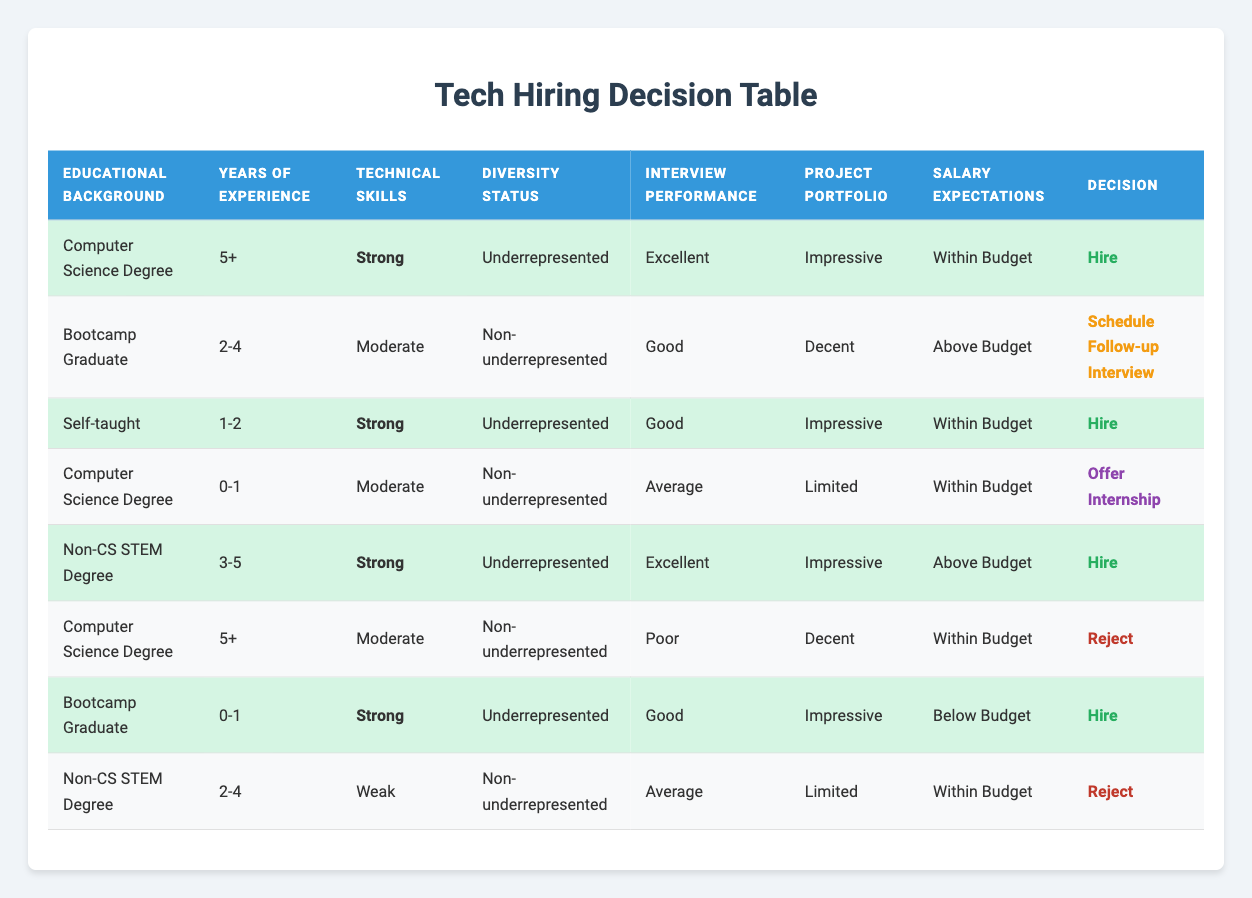What is the hiring decision for candidates with a Computer Science Degree and 5+ years of experience? According to the table, if a candidate has a Computer Science Degree and 5+ years of experience, it states they also have strong technical skills, underrepresented diversity status, excellent interview performance, an impressive project portfolio, and salary expectations within budget. Combining all these conditions leads to a hiring decision of "Hire."
Answer: Hire How many candidates were scheduled for a follow-up interview? There is one candidate in the table with the condition to schedule a follow-up interview. This candidate has a Bootcamp Graduate educational background, 2-4 years of experience, moderate technical skills, non-underrepresented diversity status, good interview performance, a decent project portfolio, and above-budget salary expectations.
Answer: 1 Is it true that all candidates with strong technical skills were hired? Reviewing the table shows that there are four candidates with strong technical skills. Out of these, three were hired and one (with a Non-CS STEM Degree, 2-4 years, and weak technical skills) was rejected. Therefore, it is false that all candidates with strong technical skills were hired.
Answer: No What is the decision for a candidate who is self-taught with 1-2 years of experience? The table indicates that a self-taught candidate with 1-2 years of experience has strong technical skills, is underrepresented in diversity, has good interview performance, an impressive project portfolio, and salary expectations within budget. The corresponding decision for them is "Hire."
Answer: Hire How does the decision for a candidate with a Non-CS STEM Degree and 3-5 years compare to one with a Computer Science Degree and 5+ years? The candidate with a Non-CS STEM Degree and 3-5 years has strong technical skills, is underrepresented, has an excellent interview performance, an impressive project portfolio, and above-budget salary expectations, leading to a decision of "Hire." The candidate with a Computer Science Degree and 5+ years has strong technical skills, is underrepresented, has excellent interview performance, an impressive project portfolio, and salary expectations within budget, which also leads to a decision of "Hire." Therefore, both candidates receive the same hiring decision, which is "Hire."
Answer: Both are hired What is the average number of years of experience for candidates hired? The candidates who are hired have the following experiences: 5+ years (1 candidate), 1-2 years (1 candidate with strong skills), and 0-1 year (1 candidate with strong skills). Therefore, the years of experience count as 5 (5+) + 1 + 0 (counting first year of internship) = 6 years counted as 3 candidates; thus, the average is 6/3 = 2.
Answer: 2 years 